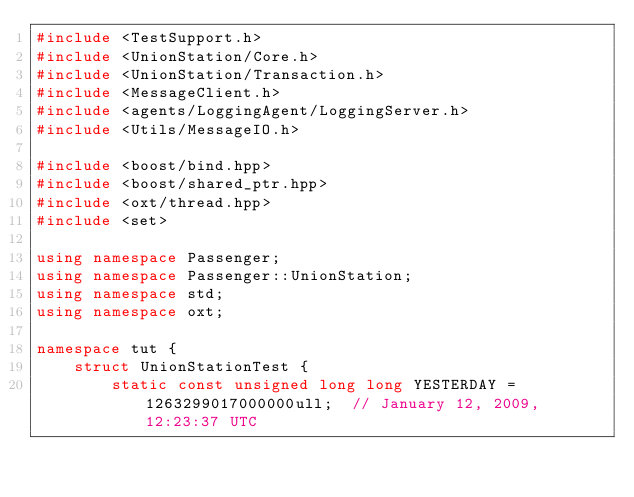Convert code to text. <code><loc_0><loc_0><loc_500><loc_500><_C++_>#include <TestSupport.h>
#include <UnionStation/Core.h>
#include <UnionStation/Transaction.h>
#include <MessageClient.h>
#include <agents/LoggingAgent/LoggingServer.h>
#include <Utils/MessageIO.h>

#include <boost/bind.hpp>
#include <boost/shared_ptr.hpp>
#include <oxt/thread.hpp>
#include <set>

using namespace Passenger;
using namespace Passenger::UnionStation;
using namespace std;
using namespace oxt;

namespace tut {
	struct UnionStationTest {
		static const unsigned long long YESTERDAY = 1263299017000000ull;  // January 12, 2009, 12:23:37 UTC</code> 